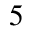Convert formula to latex. <formula><loc_0><loc_0><loc_500><loc_500>^ { 5 }</formula> 